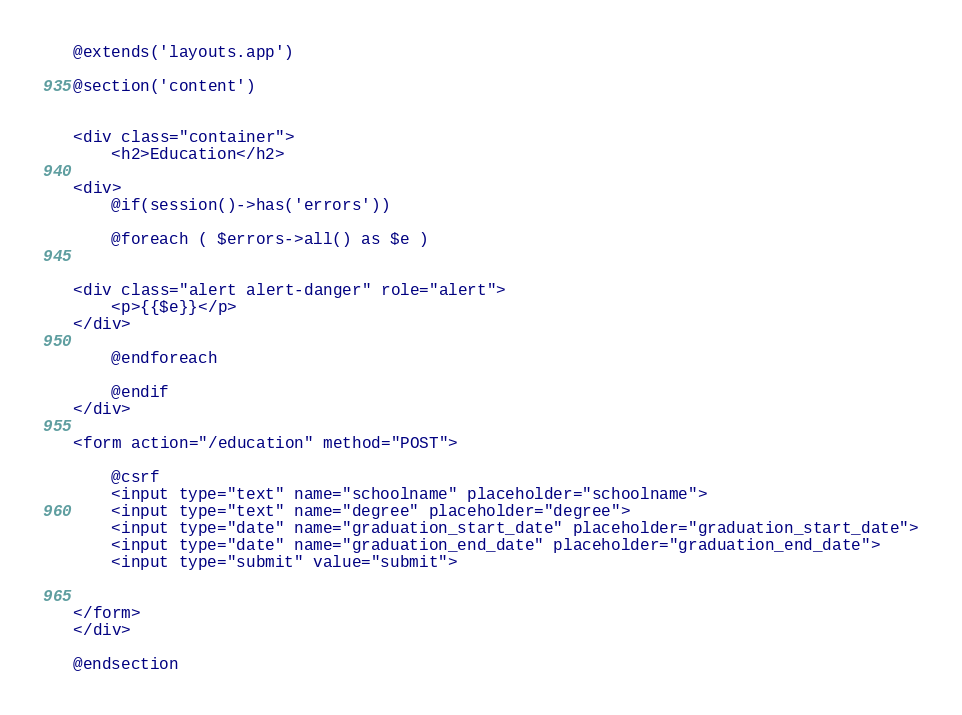<code> <loc_0><loc_0><loc_500><loc_500><_PHP_>
@extends('layouts.app')

@section('content')


<div class="container">
    <h2>Education</h2>

<div>
    @if(session()->has('errors'))

    @foreach ( $errors->all() as $e )


<div class="alert alert-danger" role="alert">
    <p>{{$e}}</p>
</div>

    @endforeach

    @endif
</div>

<form action="/education" method="POST">

    @csrf
    <input type="text" name="schoolname" placeholder="schoolname">
    <input type="text" name="degree" placeholder="degree">
    <input type="date" name="graduation_start_date" placeholder="graduation_start_date">
    <input type="date" name="graduation_end_date" placeholder="graduation_end_date">
    <input type="submit" value="submit">


</form>
</div>

@endsection

</code> 